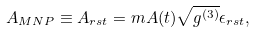<formula> <loc_0><loc_0><loc_500><loc_500>A _ { M N P } \equiv A _ { r s t } = m A ( t ) \sqrt { g ^ { ( 3 ) } } \epsilon _ { r s t } ,</formula> 